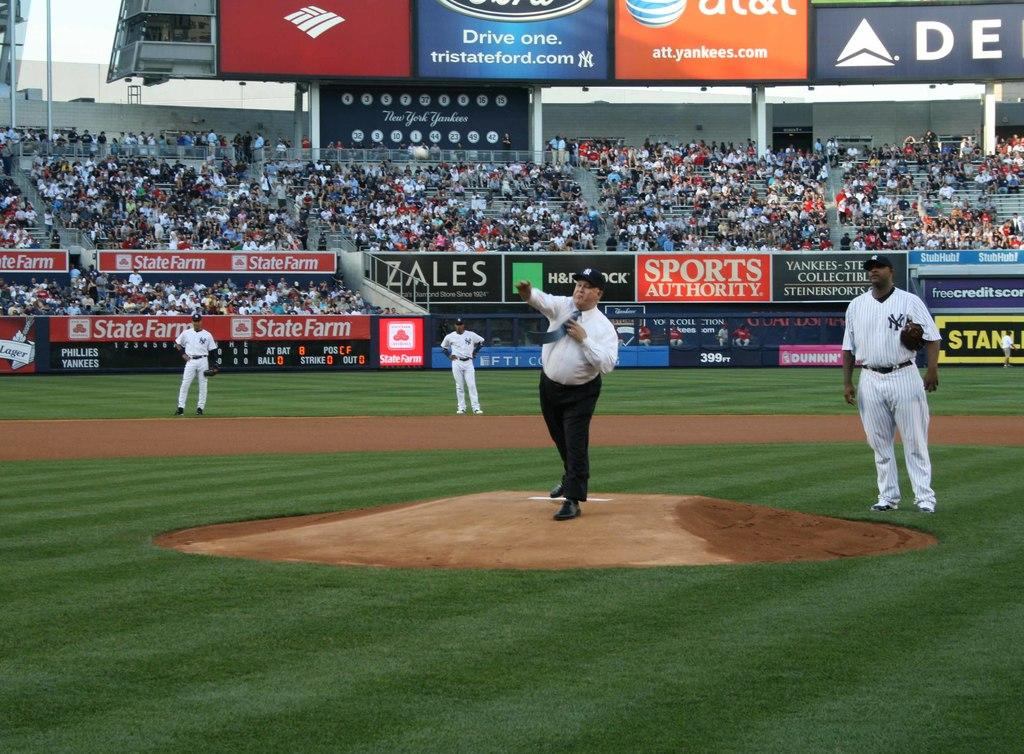<image>
Provide a brief description of the given image. An ad for Zales hangs in a baseball stadium near a Sports Authority ad. 